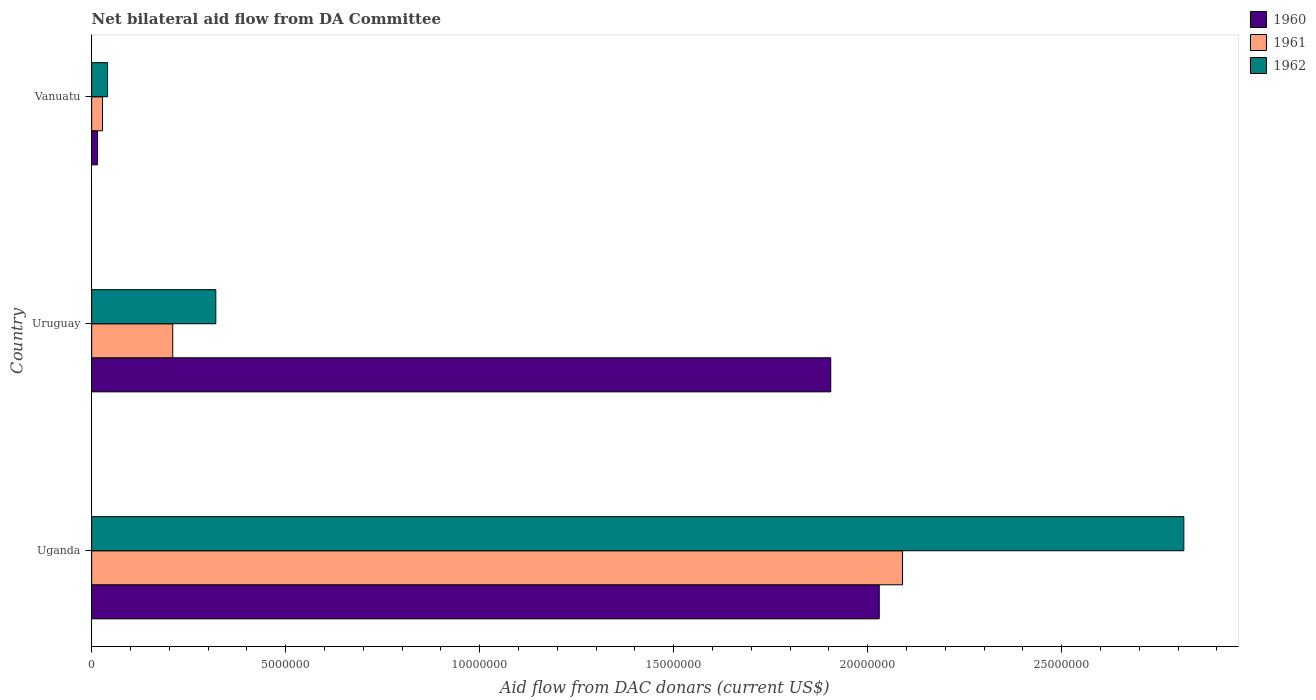Are the number of bars per tick equal to the number of legend labels?
Provide a short and direct response. Yes. How many bars are there on the 2nd tick from the top?
Offer a terse response. 3. How many bars are there on the 1st tick from the bottom?
Your answer should be very brief. 3. What is the label of the 1st group of bars from the top?
Provide a succinct answer. Vanuatu. In how many cases, is the number of bars for a given country not equal to the number of legend labels?
Give a very brief answer. 0. What is the aid flow in in 1960 in Uruguay?
Offer a very short reply. 1.90e+07. Across all countries, what is the maximum aid flow in in 1960?
Offer a terse response. 2.03e+07. In which country was the aid flow in in 1962 maximum?
Your answer should be very brief. Uganda. In which country was the aid flow in in 1960 minimum?
Your answer should be compact. Vanuatu. What is the total aid flow in in 1960 in the graph?
Provide a short and direct response. 3.95e+07. What is the difference between the aid flow in in 1960 in Uruguay and that in Vanuatu?
Provide a succinct answer. 1.89e+07. What is the difference between the aid flow in in 1961 in Uganda and the aid flow in in 1960 in Vanuatu?
Keep it short and to the point. 2.08e+07. What is the average aid flow in in 1962 per country?
Your response must be concise. 1.06e+07. What is the difference between the aid flow in in 1960 and aid flow in in 1961 in Uganda?
Give a very brief answer. -6.00e+05. In how many countries, is the aid flow in in 1960 greater than 1000000 US$?
Offer a very short reply. 2. What is the ratio of the aid flow in in 1960 in Uganda to that in Uruguay?
Provide a short and direct response. 1.07. What is the difference between the highest and the second highest aid flow in in 1960?
Give a very brief answer. 1.25e+06. What is the difference between the highest and the lowest aid flow in in 1961?
Your answer should be compact. 2.06e+07. Is it the case that in every country, the sum of the aid flow in in 1962 and aid flow in in 1961 is greater than the aid flow in in 1960?
Keep it short and to the point. No. How many bars are there?
Make the answer very short. 9. How many countries are there in the graph?
Give a very brief answer. 3. What is the difference between two consecutive major ticks on the X-axis?
Your response must be concise. 5.00e+06. Does the graph contain any zero values?
Keep it short and to the point. No. How many legend labels are there?
Your response must be concise. 3. How are the legend labels stacked?
Provide a succinct answer. Vertical. What is the title of the graph?
Give a very brief answer. Net bilateral aid flow from DA Committee. What is the label or title of the X-axis?
Make the answer very short. Aid flow from DAC donars (current US$). What is the Aid flow from DAC donars (current US$) in 1960 in Uganda?
Keep it short and to the point. 2.03e+07. What is the Aid flow from DAC donars (current US$) of 1961 in Uganda?
Keep it short and to the point. 2.09e+07. What is the Aid flow from DAC donars (current US$) in 1962 in Uganda?
Give a very brief answer. 2.82e+07. What is the Aid flow from DAC donars (current US$) in 1960 in Uruguay?
Provide a succinct answer. 1.90e+07. What is the Aid flow from DAC donars (current US$) in 1961 in Uruguay?
Your answer should be very brief. 2.09e+06. What is the Aid flow from DAC donars (current US$) of 1962 in Uruguay?
Provide a succinct answer. 3.20e+06. Across all countries, what is the maximum Aid flow from DAC donars (current US$) in 1960?
Your answer should be compact. 2.03e+07. Across all countries, what is the maximum Aid flow from DAC donars (current US$) in 1961?
Offer a terse response. 2.09e+07. Across all countries, what is the maximum Aid flow from DAC donars (current US$) in 1962?
Your answer should be compact. 2.82e+07. Across all countries, what is the minimum Aid flow from DAC donars (current US$) of 1961?
Keep it short and to the point. 2.80e+05. What is the total Aid flow from DAC donars (current US$) in 1960 in the graph?
Provide a short and direct response. 3.95e+07. What is the total Aid flow from DAC donars (current US$) in 1961 in the graph?
Provide a short and direct response. 2.33e+07. What is the total Aid flow from DAC donars (current US$) of 1962 in the graph?
Your response must be concise. 3.18e+07. What is the difference between the Aid flow from DAC donars (current US$) of 1960 in Uganda and that in Uruguay?
Your answer should be very brief. 1.25e+06. What is the difference between the Aid flow from DAC donars (current US$) of 1961 in Uganda and that in Uruguay?
Give a very brief answer. 1.88e+07. What is the difference between the Aid flow from DAC donars (current US$) in 1962 in Uganda and that in Uruguay?
Your answer should be very brief. 2.50e+07. What is the difference between the Aid flow from DAC donars (current US$) in 1960 in Uganda and that in Vanuatu?
Provide a succinct answer. 2.02e+07. What is the difference between the Aid flow from DAC donars (current US$) in 1961 in Uganda and that in Vanuatu?
Provide a short and direct response. 2.06e+07. What is the difference between the Aid flow from DAC donars (current US$) of 1962 in Uganda and that in Vanuatu?
Provide a short and direct response. 2.77e+07. What is the difference between the Aid flow from DAC donars (current US$) of 1960 in Uruguay and that in Vanuatu?
Ensure brevity in your answer.  1.89e+07. What is the difference between the Aid flow from DAC donars (current US$) in 1961 in Uruguay and that in Vanuatu?
Give a very brief answer. 1.81e+06. What is the difference between the Aid flow from DAC donars (current US$) of 1962 in Uruguay and that in Vanuatu?
Give a very brief answer. 2.79e+06. What is the difference between the Aid flow from DAC donars (current US$) in 1960 in Uganda and the Aid flow from DAC donars (current US$) in 1961 in Uruguay?
Keep it short and to the point. 1.82e+07. What is the difference between the Aid flow from DAC donars (current US$) in 1960 in Uganda and the Aid flow from DAC donars (current US$) in 1962 in Uruguay?
Your response must be concise. 1.71e+07. What is the difference between the Aid flow from DAC donars (current US$) in 1961 in Uganda and the Aid flow from DAC donars (current US$) in 1962 in Uruguay?
Provide a succinct answer. 1.77e+07. What is the difference between the Aid flow from DAC donars (current US$) of 1960 in Uganda and the Aid flow from DAC donars (current US$) of 1961 in Vanuatu?
Your answer should be very brief. 2.00e+07. What is the difference between the Aid flow from DAC donars (current US$) of 1960 in Uganda and the Aid flow from DAC donars (current US$) of 1962 in Vanuatu?
Your answer should be compact. 1.99e+07. What is the difference between the Aid flow from DAC donars (current US$) of 1961 in Uganda and the Aid flow from DAC donars (current US$) of 1962 in Vanuatu?
Make the answer very short. 2.05e+07. What is the difference between the Aid flow from DAC donars (current US$) in 1960 in Uruguay and the Aid flow from DAC donars (current US$) in 1961 in Vanuatu?
Provide a succinct answer. 1.88e+07. What is the difference between the Aid flow from DAC donars (current US$) of 1960 in Uruguay and the Aid flow from DAC donars (current US$) of 1962 in Vanuatu?
Keep it short and to the point. 1.86e+07. What is the difference between the Aid flow from DAC donars (current US$) in 1961 in Uruguay and the Aid flow from DAC donars (current US$) in 1962 in Vanuatu?
Offer a terse response. 1.68e+06. What is the average Aid flow from DAC donars (current US$) of 1960 per country?
Keep it short and to the point. 1.32e+07. What is the average Aid flow from DAC donars (current US$) of 1961 per country?
Provide a short and direct response. 7.76e+06. What is the average Aid flow from DAC donars (current US$) of 1962 per country?
Provide a succinct answer. 1.06e+07. What is the difference between the Aid flow from DAC donars (current US$) of 1960 and Aid flow from DAC donars (current US$) of 1961 in Uganda?
Your response must be concise. -6.00e+05. What is the difference between the Aid flow from DAC donars (current US$) in 1960 and Aid flow from DAC donars (current US$) in 1962 in Uganda?
Provide a short and direct response. -7.85e+06. What is the difference between the Aid flow from DAC donars (current US$) in 1961 and Aid flow from DAC donars (current US$) in 1962 in Uganda?
Ensure brevity in your answer.  -7.25e+06. What is the difference between the Aid flow from DAC donars (current US$) of 1960 and Aid flow from DAC donars (current US$) of 1961 in Uruguay?
Make the answer very short. 1.70e+07. What is the difference between the Aid flow from DAC donars (current US$) in 1960 and Aid flow from DAC donars (current US$) in 1962 in Uruguay?
Keep it short and to the point. 1.58e+07. What is the difference between the Aid flow from DAC donars (current US$) of 1961 and Aid flow from DAC donars (current US$) of 1962 in Uruguay?
Your response must be concise. -1.11e+06. What is the difference between the Aid flow from DAC donars (current US$) of 1960 and Aid flow from DAC donars (current US$) of 1962 in Vanuatu?
Give a very brief answer. -2.60e+05. What is the ratio of the Aid flow from DAC donars (current US$) in 1960 in Uganda to that in Uruguay?
Offer a very short reply. 1.07. What is the ratio of the Aid flow from DAC donars (current US$) in 1961 in Uganda to that in Uruguay?
Offer a terse response. 10. What is the ratio of the Aid flow from DAC donars (current US$) of 1962 in Uganda to that in Uruguay?
Ensure brevity in your answer.  8.8. What is the ratio of the Aid flow from DAC donars (current US$) in 1960 in Uganda to that in Vanuatu?
Your response must be concise. 135.33. What is the ratio of the Aid flow from DAC donars (current US$) in 1961 in Uganda to that in Vanuatu?
Make the answer very short. 74.64. What is the ratio of the Aid flow from DAC donars (current US$) of 1962 in Uganda to that in Vanuatu?
Your answer should be compact. 68.66. What is the ratio of the Aid flow from DAC donars (current US$) of 1960 in Uruguay to that in Vanuatu?
Provide a short and direct response. 127. What is the ratio of the Aid flow from DAC donars (current US$) in 1961 in Uruguay to that in Vanuatu?
Offer a terse response. 7.46. What is the ratio of the Aid flow from DAC donars (current US$) of 1962 in Uruguay to that in Vanuatu?
Provide a succinct answer. 7.8. What is the difference between the highest and the second highest Aid flow from DAC donars (current US$) of 1960?
Keep it short and to the point. 1.25e+06. What is the difference between the highest and the second highest Aid flow from DAC donars (current US$) of 1961?
Offer a very short reply. 1.88e+07. What is the difference between the highest and the second highest Aid flow from DAC donars (current US$) in 1962?
Offer a very short reply. 2.50e+07. What is the difference between the highest and the lowest Aid flow from DAC donars (current US$) of 1960?
Provide a short and direct response. 2.02e+07. What is the difference between the highest and the lowest Aid flow from DAC donars (current US$) in 1961?
Offer a terse response. 2.06e+07. What is the difference between the highest and the lowest Aid flow from DAC donars (current US$) in 1962?
Offer a terse response. 2.77e+07. 